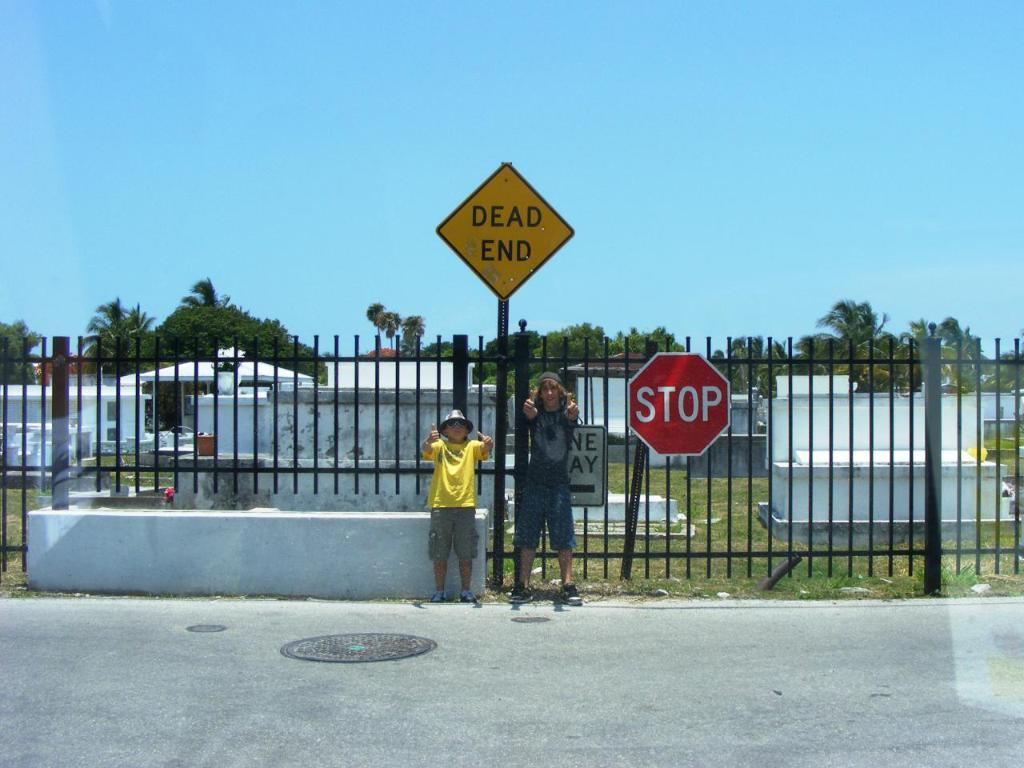Provide a one-sentence caption for the provided image. a child and an adulat man are posing for a picture next to a sign that reads dead end and in front of a cemetery. 